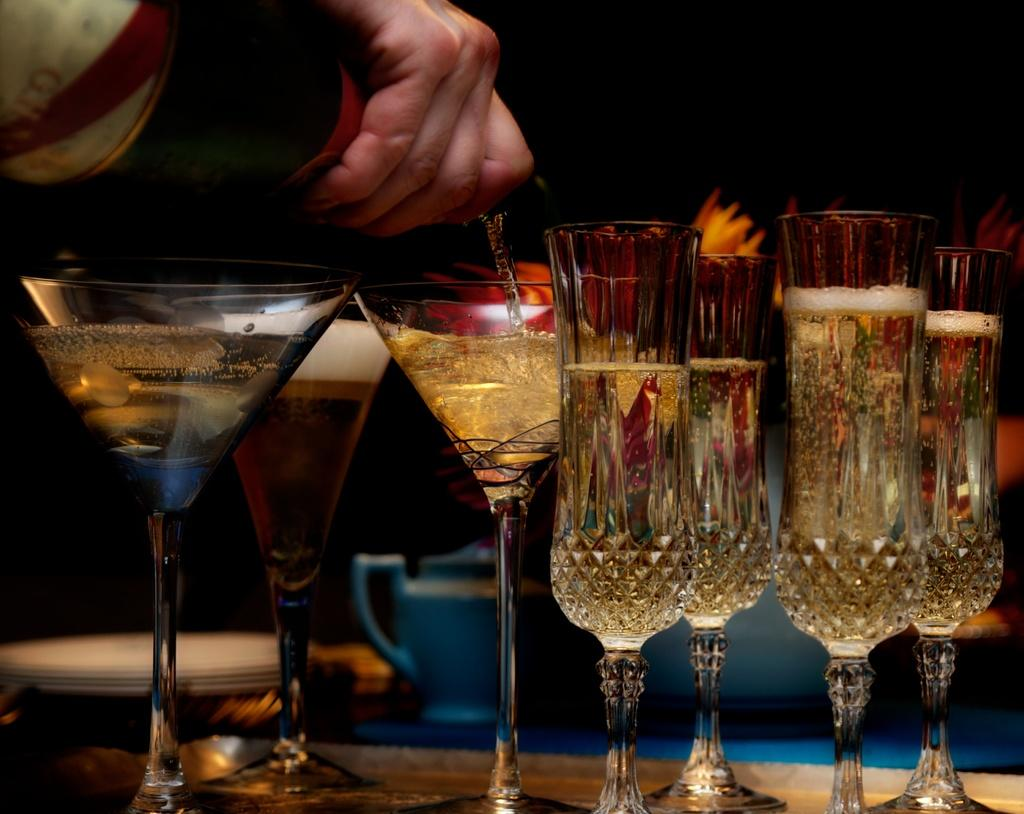What objects are in the image that are typically used for drinking? There are glasses in the image that are typically used for drinking. What is the person holding in the image? A person's hand is holding a whisky bottle in the image. Where are the glasses located in the image? The glasses are on a table in the image. How does the snow affect the glasses on the table in the image? There is no snow present in the image, so it cannot affect the glasses on the table. 